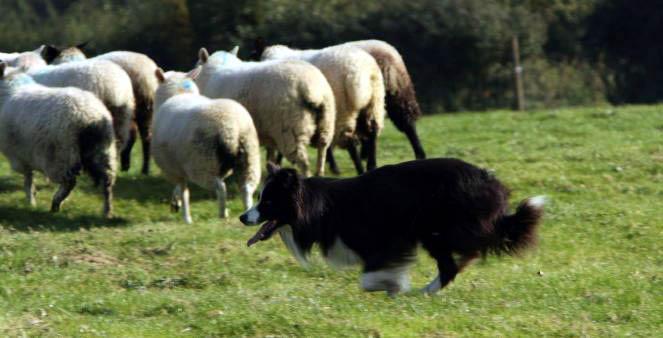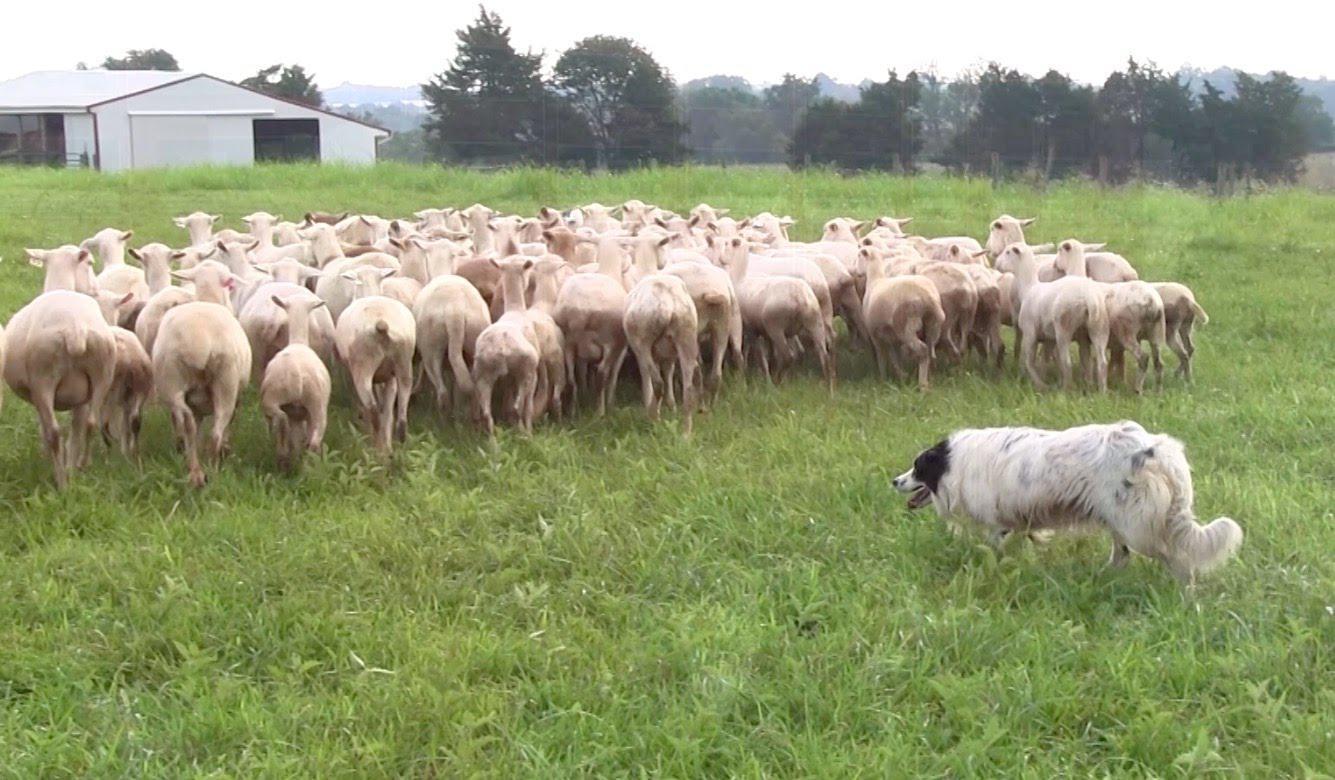The first image is the image on the left, the second image is the image on the right. For the images shown, is this caption "There are more sheep in the image on the left." true? Answer yes or no. No. The first image is the image on the left, the second image is the image on the right. For the images shown, is this caption "One image shows a dog to the right of sheep, and the other shows a dog to the left of sheep." true? Answer yes or no. No. 